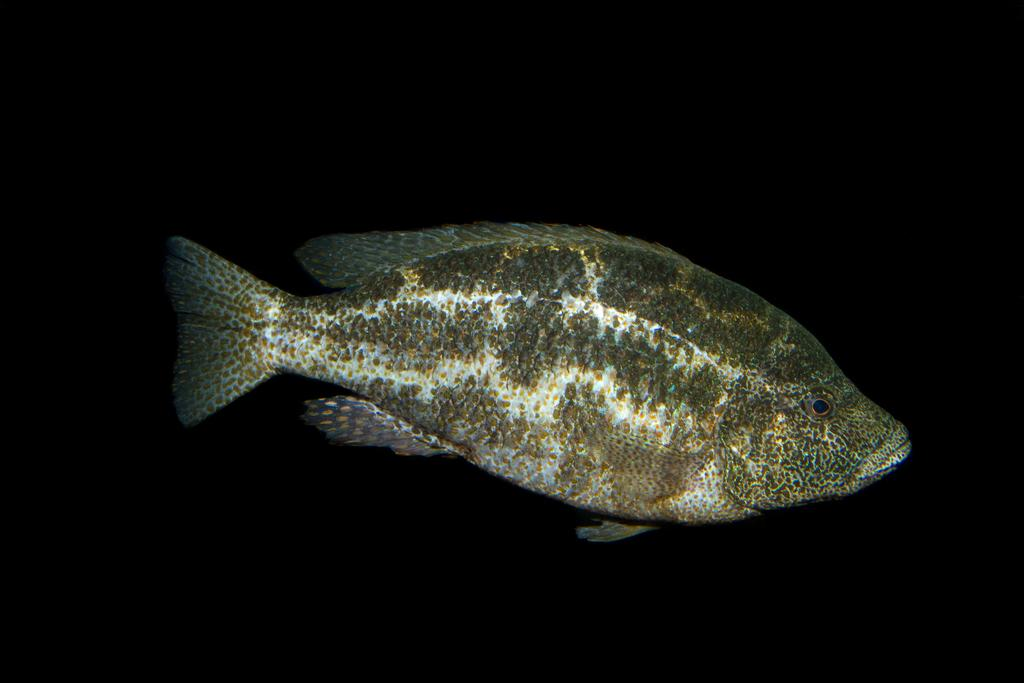What is the main subject of the image? There is a fish in the image. What color is the background of the image? The background of the image is black. How many birds are sitting on the vase in the image? There is no vase or bird present in the image; it features a fish with a black background. 